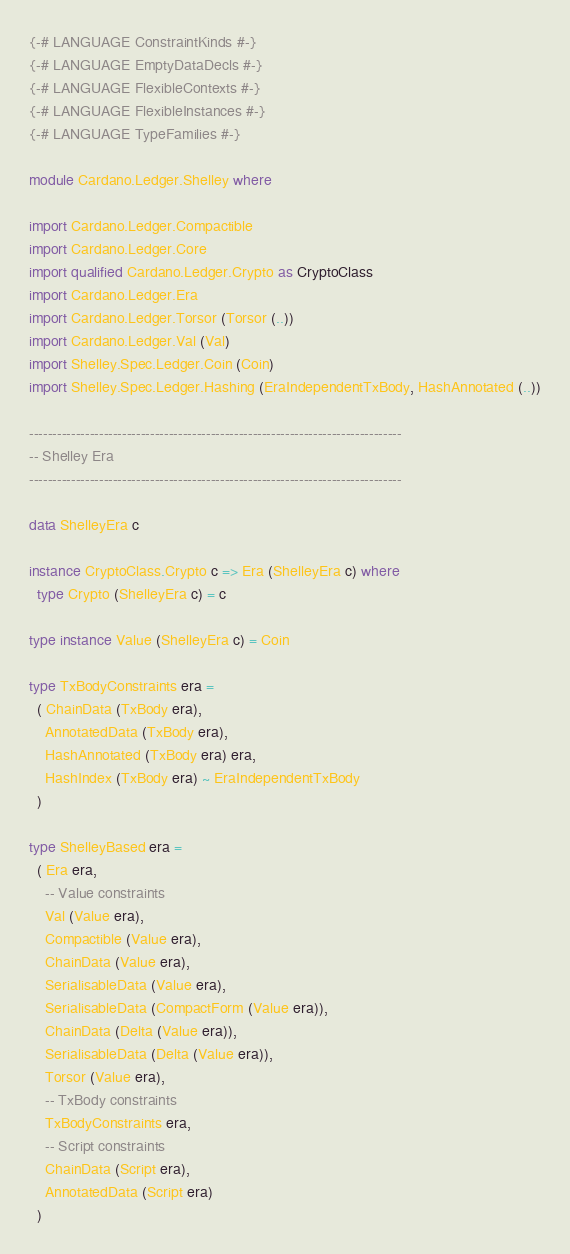<code> <loc_0><loc_0><loc_500><loc_500><_Haskell_>{-# LANGUAGE ConstraintKinds #-}
{-# LANGUAGE EmptyDataDecls #-}
{-# LANGUAGE FlexibleContexts #-}
{-# LANGUAGE FlexibleInstances #-}
{-# LANGUAGE TypeFamilies #-}

module Cardano.Ledger.Shelley where

import Cardano.Ledger.Compactible
import Cardano.Ledger.Core
import qualified Cardano.Ledger.Crypto as CryptoClass
import Cardano.Ledger.Era
import Cardano.Ledger.Torsor (Torsor (..))
import Cardano.Ledger.Val (Val)
import Shelley.Spec.Ledger.Coin (Coin)
import Shelley.Spec.Ledger.Hashing (EraIndependentTxBody, HashAnnotated (..))

--------------------------------------------------------------------------------
-- Shelley Era
--------------------------------------------------------------------------------

data ShelleyEra c

instance CryptoClass.Crypto c => Era (ShelleyEra c) where
  type Crypto (ShelleyEra c) = c

type instance Value (ShelleyEra c) = Coin

type TxBodyConstraints era =
  ( ChainData (TxBody era),
    AnnotatedData (TxBody era),
    HashAnnotated (TxBody era) era,
    HashIndex (TxBody era) ~ EraIndependentTxBody
  )

type ShelleyBased era =
  ( Era era,
    -- Value constraints
    Val (Value era),
    Compactible (Value era),
    ChainData (Value era),
    SerialisableData (Value era),
    SerialisableData (CompactForm (Value era)),
    ChainData (Delta (Value era)),
    SerialisableData (Delta (Value era)),
    Torsor (Value era),
    -- TxBody constraints
    TxBodyConstraints era,
    -- Script constraints
    ChainData (Script era),
    AnnotatedData (Script era)
  )
</code> 